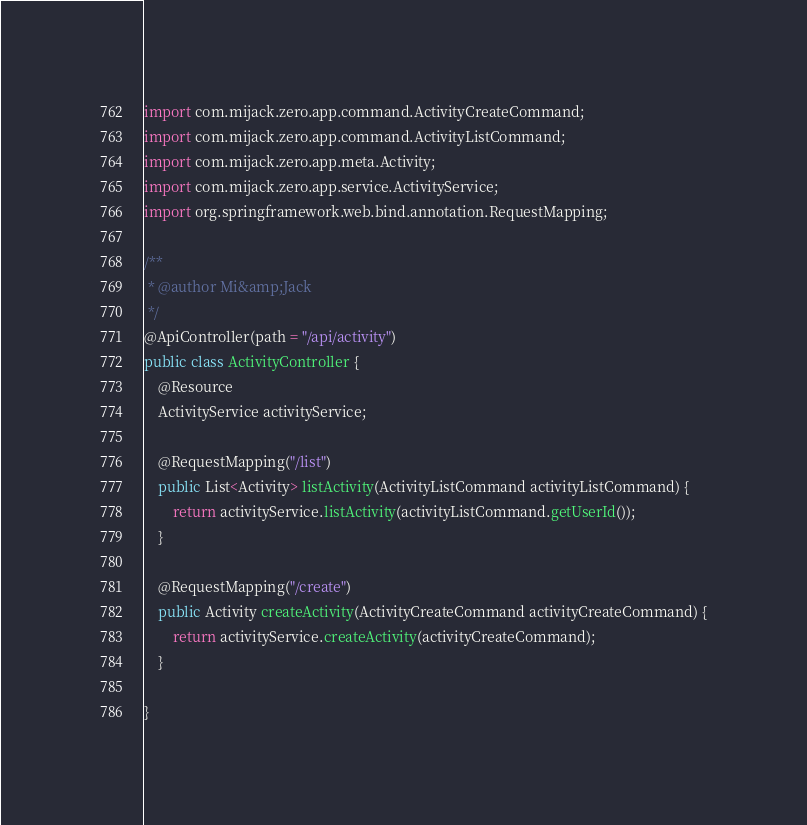<code> <loc_0><loc_0><loc_500><loc_500><_Java_>import com.mijack.zero.app.command.ActivityCreateCommand;
import com.mijack.zero.app.command.ActivityListCommand;
import com.mijack.zero.app.meta.Activity;
import com.mijack.zero.app.service.ActivityService;
import org.springframework.web.bind.annotation.RequestMapping;

/**
 * @author Mi&amp;Jack
 */
@ApiController(path = "/api/activity")
public class ActivityController {
    @Resource
    ActivityService activityService;

    @RequestMapping("/list")
    public List<Activity> listActivity(ActivityListCommand activityListCommand) {
        return activityService.listActivity(activityListCommand.getUserId());
    }

    @RequestMapping("/create")
    public Activity createActivity(ActivityCreateCommand activityCreateCommand) {
        return activityService.createActivity(activityCreateCommand);
    }

}
</code> 